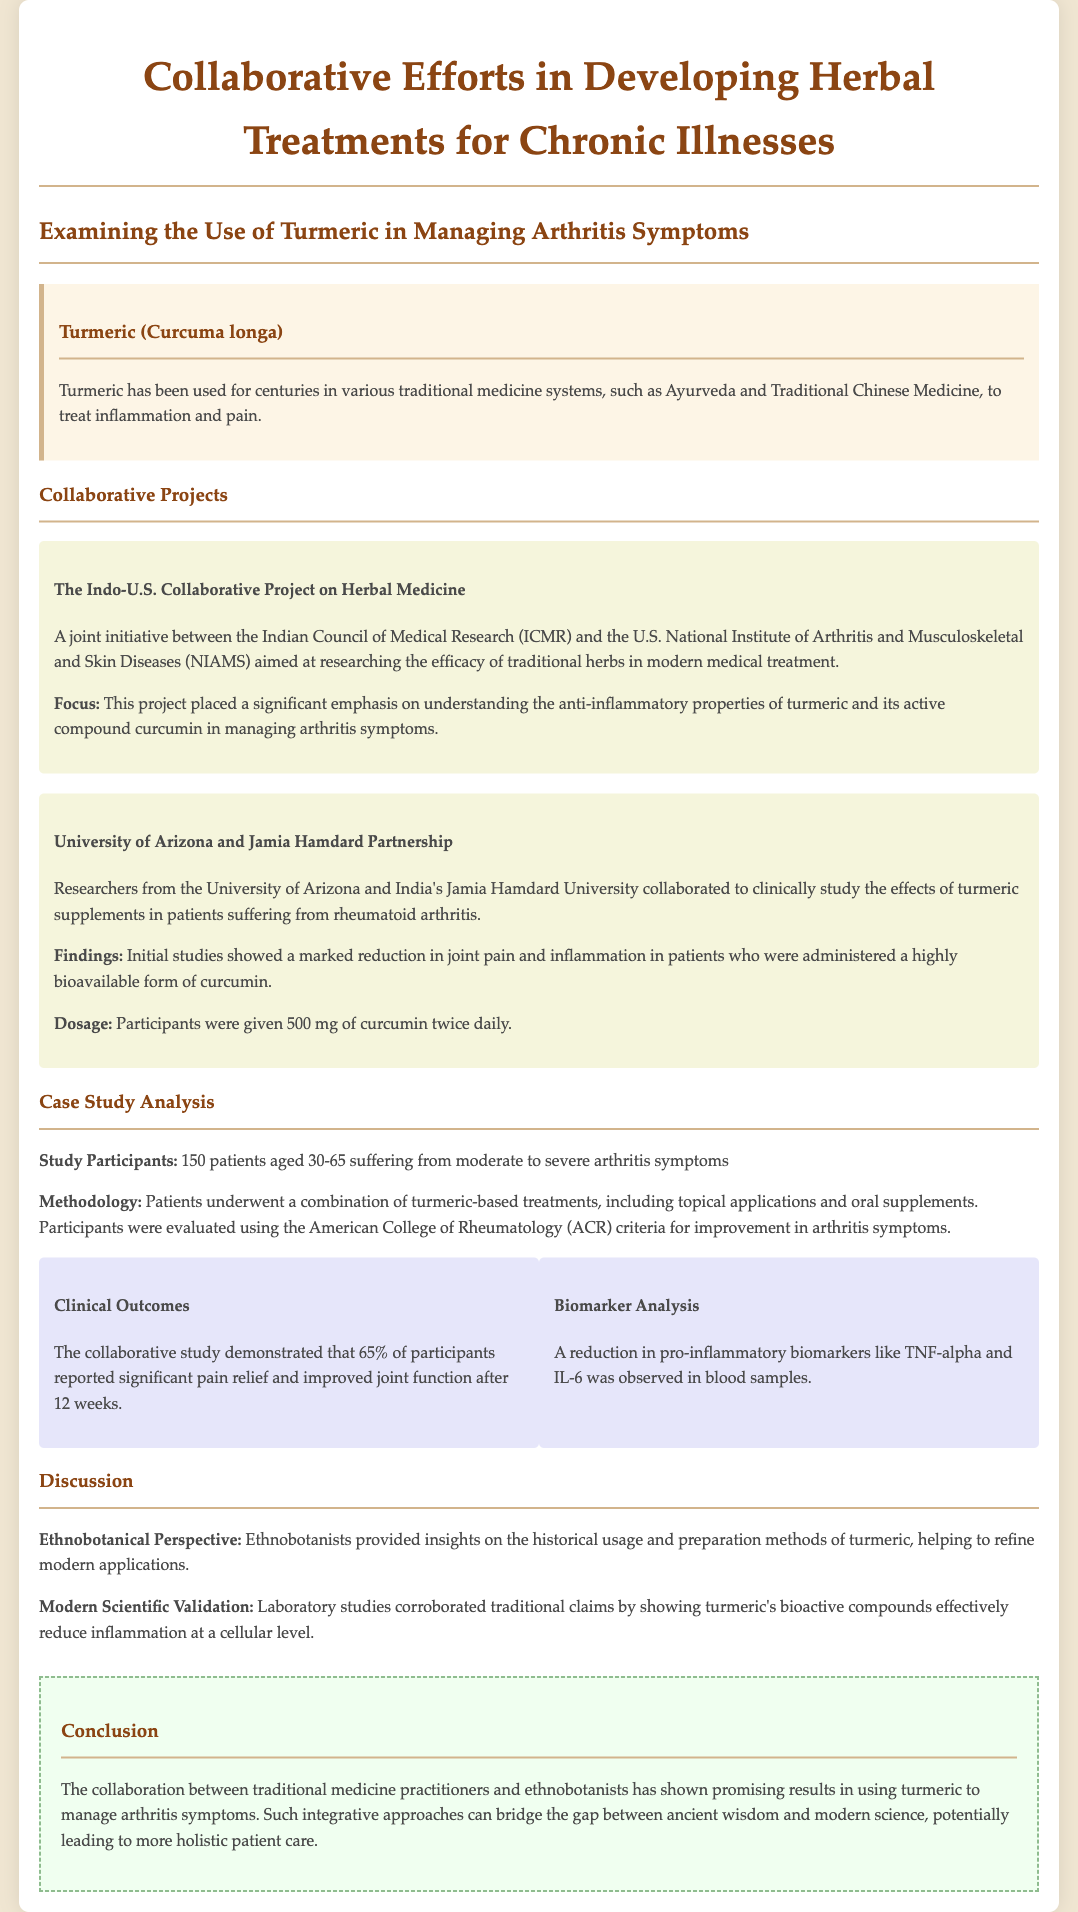what is the primary herb studied for managing arthritis symptoms? The document highlights the use of turmeric in managing arthritis symptoms.
Answer: turmeric how many patients participated in the case study? The document states that 150 patients participated in the study.
Answer: 150 what is the name of the Indian research institution involved in the collaborative project? The document mentions the Indian Council of Medical Research (ICMR) as the institution involved.
Answer: ICMR what percentage of participants reported significant pain relief after 12 weeks? According to the document, 65% of participants reported significant pain relief after 12 weeks.
Answer: 65% what was the dosage of curcumin administered to participants? The document specifies that participants were given 500 mg of curcumin twice daily.
Answer: 500 mg twice daily which biomarkers showed a reduction according to the biomarker analysis? The document indicates a reduction in pro-inflammatory biomarkers like TNF-alpha and IL-6.
Answer: TNF-alpha and IL-6 what role did ethnobotanists play in the study? Ethnobotanists provided insights on the historical usage and preparation methods of turmeric.
Answer: insights on historical usage what is the focus of the Indo-U.S. Collaborative Project on Herbal Medicine? The project focuses on understanding the anti-inflammatory properties of turmeric.
Answer: anti-inflammatory properties what methodology was used for evaluating improvement in arthritis symptoms? The document states that participants were evaluated using the American College of Rheumatology (ACR) criteria.
Answer: ACR criteria 